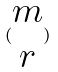<formula> <loc_0><loc_0><loc_500><loc_500>( \begin{matrix} m \\ r \end{matrix} )</formula> 